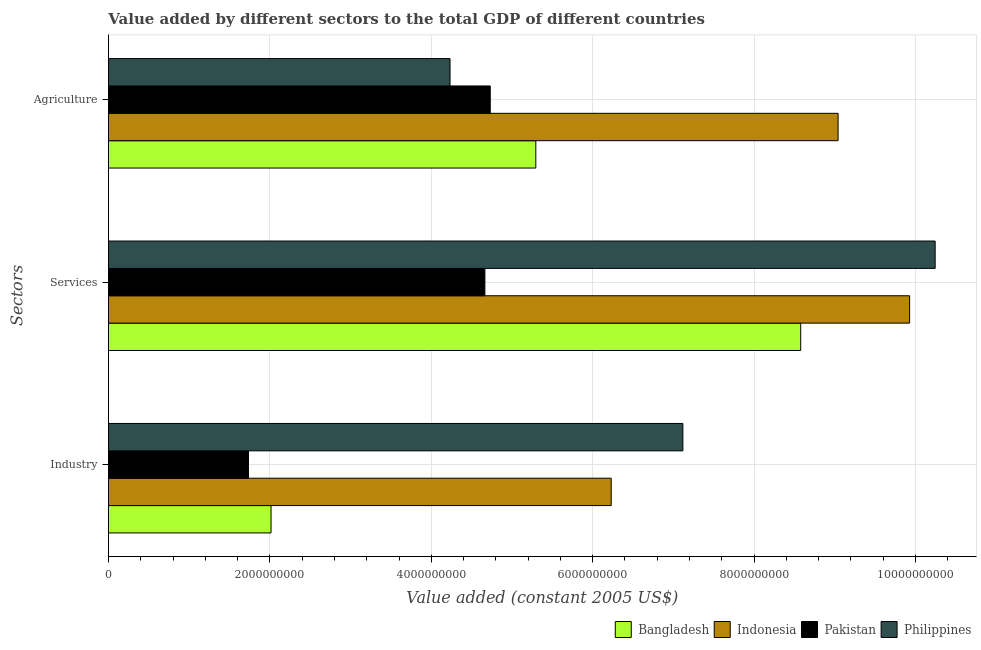How many groups of bars are there?
Offer a very short reply. 3. Are the number of bars per tick equal to the number of legend labels?
Offer a terse response. Yes. Are the number of bars on each tick of the Y-axis equal?
Your answer should be very brief. Yes. How many bars are there on the 3rd tick from the top?
Keep it short and to the point. 4. How many bars are there on the 2nd tick from the bottom?
Provide a succinct answer. 4. What is the label of the 2nd group of bars from the top?
Provide a succinct answer. Services. What is the value added by industrial sector in Philippines?
Offer a very short reply. 7.12e+09. Across all countries, what is the maximum value added by services?
Offer a terse response. 1.02e+1. Across all countries, what is the minimum value added by industrial sector?
Make the answer very short. 1.74e+09. In which country was the value added by industrial sector maximum?
Offer a very short reply. Philippines. What is the total value added by services in the graph?
Ensure brevity in your answer.  3.34e+1. What is the difference between the value added by services in Philippines and that in Pakistan?
Offer a very short reply. 5.58e+09. What is the difference between the value added by agricultural sector in Pakistan and the value added by services in Bangladesh?
Your answer should be very brief. -3.85e+09. What is the average value added by industrial sector per country?
Keep it short and to the point. 4.27e+09. What is the difference between the value added by industrial sector and value added by agricultural sector in Indonesia?
Provide a succinct answer. -2.81e+09. In how many countries, is the value added by services greater than 5600000000 US$?
Your response must be concise. 3. What is the ratio of the value added by industrial sector in Philippines to that in Indonesia?
Offer a very short reply. 1.14. Is the value added by agricultural sector in Pakistan less than that in Philippines?
Your answer should be very brief. No. What is the difference between the highest and the second highest value added by services?
Provide a short and direct response. 3.16e+08. What is the difference between the highest and the lowest value added by services?
Your answer should be compact. 5.58e+09. In how many countries, is the value added by agricultural sector greater than the average value added by agricultural sector taken over all countries?
Provide a short and direct response. 1. What does the 2nd bar from the top in Industry represents?
Your answer should be compact. Pakistan. How many countries are there in the graph?
Your response must be concise. 4. What is the difference between two consecutive major ticks on the X-axis?
Your response must be concise. 2.00e+09. Does the graph contain any zero values?
Offer a very short reply. No. Does the graph contain grids?
Provide a short and direct response. Yes. How many legend labels are there?
Your answer should be very brief. 4. What is the title of the graph?
Provide a short and direct response. Value added by different sectors to the total GDP of different countries. Does "Guinea" appear as one of the legend labels in the graph?
Your answer should be very brief. No. What is the label or title of the X-axis?
Your response must be concise. Value added (constant 2005 US$). What is the label or title of the Y-axis?
Your response must be concise. Sectors. What is the Value added (constant 2005 US$) of Bangladesh in Industry?
Your response must be concise. 2.01e+09. What is the Value added (constant 2005 US$) of Indonesia in Industry?
Make the answer very short. 6.23e+09. What is the Value added (constant 2005 US$) in Pakistan in Industry?
Provide a succinct answer. 1.74e+09. What is the Value added (constant 2005 US$) in Philippines in Industry?
Provide a short and direct response. 7.12e+09. What is the Value added (constant 2005 US$) of Bangladesh in Services?
Your answer should be compact. 8.58e+09. What is the Value added (constant 2005 US$) in Indonesia in Services?
Your answer should be compact. 9.93e+09. What is the Value added (constant 2005 US$) of Pakistan in Services?
Provide a succinct answer. 4.66e+09. What is the Value added (constant 2005 US$) of Philippines in Services?
Your answer should be compact. 1.02e+1. What is the Value added (constant 2005 US$) of Bangladesh in Agriculture?
Provide a short and direct response. 5.30e+09. What is the Value added (constant 2005 US$) in Indonesia in Agriculture?
Provide a succinct answer. 9.04e+09. What is the Value added (constant 2005 US$) in Pakistan in Agriculture?
Make the answer very short. 4.73e+09. What is the Value added (constant 2005 US$) in Philippines in Agriculture?
Keep it short and to the point. 4.23e+09. Across all Sectors, what is the maximum Value added (constant 2005 US$) of Bangladesh?
Keep it short and to the point. 8.58e+09. Across all Sectors, what is the maximum Value added (constant 2005 US$) in Indonesia?
Give a very brief answer. 9.93e+09. Across all Sectors, what is the maximum Value added (constant 2005 US$) of Pakistan?
Your answer should be very brief. 4.73e+09. Across all Sectors, what is the maximum Value added (constant 2005 US$) of Philippines?
Ensure brevity in your answer.  1.02e+1. Across all Sectors, what is the minimum Value added (constant 2005 US$) of Bangladesh?
Keep it short and to the point. 2.01e+09. Across all Sectors, what is the minimum Value added (constant 2005 US$) of Indonesia?
Your response must be concise. 6.23e+09. Across all Sectors, what is the minimum Value added (constant 2005 US$) in Pakistan?
Provide a short and direct response. 1.74e+09. Across all Sectors, what is the minimum Value added (constant 2005 US$) in Philippines?
Keep it short and to the point. 4.23e+09. What is the total Value added (constant 2005 US$) in Bangladesh in the graph?
Provide a succinct answer. 1.59e+1. What is the total Value added (constant 2005 US$) in Indonesia in the graph?
Make the answer very short. 2.52e+1. What is the total Value added (constant 2005 US$) of Pakistan in the graph?
Your response must be concise. 1.11e+1. What is the total Value added (constant 2005 US$) of Philippines in the graph?
Ensure brevity in your answer.  2.16e+1. What is the difference between the Value added (constant 2005 US$) of Bangladesh in Industry and that in Services?
Your answer should be very brief. -6.56e+09. What is the difference between the Value added (constant 2005 US$) of Indonesia in Industry and that in Services?
Ensure brevity in your answer.  -3.70e+09. What is the difference between the Value added (constant 2005 US$) in Pakistan in Industry and that in Services?
Make the answer very short. -2.93e+09. What is the difference between the Value added (constant 2005 US$) of Philippines in Industry and that in Services?
Keep it short and to the point. -3.13e+09. What is the difference between the Value added (constant 2005 US$) of Bangladesh in Industry and that in Agriculture?
Keep it short and to the point. -3.28e+09. What is the difference between the Value added (constant 2005 US$) in Indonesia in Industry and that in Agriculture?
Make the answer very short. -2.81e+09. What is the difference between the Value added (constant 2005 US$) in Pakistan in Industry and that in Agriculture?
Keep it short and to the point. -3.00e+09. What is the difference between the Value added (constant 2005 US$) in Philippines in Industry and that in Agriculture?
Provide a succinct answer. 2.89e+09. What is the difference between the Value added (constant 2005 US$) of Bangladesh in Services and that in Agriculture?
Give a very brief answer. 3.28e+09. What is the difference between the Value added (constant 2005 US$) of Indonesia in Services and that in Agriculture?
Ensure brevity in your answer.  8.86e+08. What is the difference between the Value added (constant 2005 US$) of Pakistan in Services and that in Agriculture?
Your answer should be very brief. -6.64e+07. What is the difference between the Value added (constant 2005 US$) of Philippines in Services and that in Agriculture?
Offer a very short reply. 6.01e+09. What is the difference between the Value added (constant 2005 US$) of Bangladesh in Industry and the Value added (constant 2005 US$) of Indonesia in Services?
Offer a terse response. -7.91e+09. What is the difference between the Value added (constant 2005 US$) in Bangladesh in Industry and the Value added (constant 2005 US$) in Pakistan in Services?
Offer a terse response. -2.65e+09. What is the difference between the Value added (constant 2005 US$) of Bangladesh in Industry and the Value added (constant 2005 US$) of Philippines in Services?
Provide a succinct answer. -8.23e+09. What is the difference between the Value added (constant 2005 US$) in Indonesia in Industry and the Value added (constant 2005 US$) in Pakistan in Services?
Your response must be concise. 1.56e+09. What is the difference between the Value added (constant 2005 US$) in Indonesia in Industry and the Value added (constant 2005 US$) in Philippines in Services?
Keep it short and to the point. -4.01e+09. What is the difference between the Value added (constant 2005 US$) in Pakistan in Industry and the Value added (constant 2005 US$) in Philippines in Services?
Your answer should be compact. -8.51e+09. What is the difference between the Value added (constant 2005 US$) in Bangladesh in Industry and the Value added (constant 2005 US$) in Indonesia in Agriculture?
Your answer should be very brief. -7.03e+09. What is the difference between the Value added (constant 2005 US$) in Bangladesh in Industry and the Value added (constant 2005 US$) in Pakistan in Agriculture?
Your answer should be very brief. -2.72e+09. What is the difference between the Value added (constant 2005 US$) in Bangladesh in Industry and the Value added (constant 2005 US$) in Philippines in Agriculture?
Offer a terse response. -2.22e+09. What is the difference between the Value added (constant 2005 US$) in Indonesia in Industry and the Value added (constant 2005 US$) in Pakistan in Agriculture?
Provide a short and direct response. 1.50e+09. What is the difference between the Value added (constant 2005 US$) of Indonesia in Industry and the Value added (constant 2005 US$) of Philippines in Agriculture?
Offer a very short reply. 2.00e+09. What is the difference between the Value added (constant 2005 US$) in Pakistan in Industry and the Value added (constant 2005 US$) in Philippines in Agriculture?
Provide a short and direct response. -2.50e+09. What is the difference between the Value added (constant 2005 US$) of Bangladesh in Services and the Value added (constant 2005 US$) of Indonesia in Agriculture?
Keep it short and to the point. -4.63e+08. What is the difference between the Value added (constant 2005 US$) in Bangladesh in Services and the Value added (constant 2005 US$) in Pakistan in Agriculture?
Keep it short and to the point. 3.85e+09. What is the difference between the Value added (constant 2005 US$) in Bangladesh in Services and the Value added (constant 2005 US$) in Philippines in Agriculture?
Keep it short and to the point. 4.34e+09. What is the difference between the Value added (constant 2005 US$) of Indonesia in Services and the Value added (constant 2005 US$) of Pakistan in Agriculture?
Ensure brevity in your answer.  5.20e+09. What is the difference between the Value added (constant 2005 US$) of Indonesia in Services and the Value added (constant 2005 US$) of Philippines in Agriculture?
Ensure brevity in your answer.  5.69e+09. What is the difference between the Value added (constant 2005 US$) in Pakistan in Services and the Value added (constant 2005 US$) in Philippines in Agriculture?
Your answer should be very brief. 4.32e+08. What is the average Value added (constant 2005 US$) of Bangladesh per Sectors?
Ensure brevity in your answer.  5.30e+09. What is the average Value added (constant 2005 US$) in Indonesia per Sectors?
Offer a terse response. 8.40e+09. What is the average Value added (constant 2005 US$) of Pakistan per Sectors?
Offer a very short reply. 3.71e+09. What is the average Value added (constant 2005 US$) of Philippines per Sectors?
Your answer should be very brief. 7.20e+09. What is the difference between the Value added (constant 2005 US$) of Bangladesh and Value added (constant 2005 US$) of Indonesia in Industry?
Provide a short and direct response. -4.21e+09. What is the difference between the Value added (constant 2005 US$) of Bangladesh and Value added (constant 2005 US$) of Pakistan in Industry?
Your answer should be very brief. 2.80e+08. What is the difference between the Value added (constant 2005 US$) in Bangladesh and Value added (constant 2005 US$) in Philippines in Industry?
Provide a succinct answer. -5.10e+09. What is the difference between the Value added (constant 2005 US$) of Indonesia and Value added (constant 2005 US$) of Pakistan in Industry?
Your answer should be compact. 4.49e+09. What is the difference between the Value added (constant 2005 US$) of Indonesia and Value added (constant 2005 US$) of Philippines in Industry?
Your answer should be very brief. -8.88e+08. What is the difference between the Value added (constant 2005 US$) of Pakistan and Value added (constant 2005 US$) of Philippines in Industry?
Provide a short and direct response. -5.38e+09. What is the difference between the Value added (constant 2005 US$) in Bangladesh and Value added (constant 2005 US$) in Indonesia in Services?
Provide a succinct answer. -1.35e+09. What is the difference between the Value added (constant 2005 US$) of Bangladesh and Value added (constant 2005 US$) of Pakistan in Services?
Give a very brief answer. 3.91e+09. What is the difference between the Value added (constant 2005 US$) of Bangladesh and Value added (constant 2005 US$) of Philippines in Services?
Offer a terse response. -1.67e+09. What is the difference between the Value added (constant 2005 US$) in Indonesia and Value added (constant 2005 US$) in Pakistan in Services?
Your response must be concise. 5.26e+09. What is the difference between the Value added (constant 2005 US$) of Indonesia and Value added (constant 2005 US$) of Philippines in Services?
Provide a short and direct response. -3.16e+08. What is the difference between the Value added (constant 2005 US$) in Pakistan and Value added (constant 2005 US$) in Philippines in Services?
Make the answer very short. -5.58e+09. What is the difference between the Value added (constant 2005 US$) of Bangladesh and Value added (constant 2005 US$) of Indonesia in Agriculture?
Give a very brief answer. -3.75e+09. What is the difference between the Value added (constant 2005 US$) of Bangladesh and Value added (constant 2005 US$) of Pakistan in Agriculture?
Your response must be concise. 5.65e+08. What is the difference between the Value added (constant 2005 US$) in Bangladesh and Value added (constant 2005 US$) in Philippines in Agriculture?
Give a very brief answer. 1.06e+09. What is the difference between the Value added (constant 2005 US$) of Indonesia and Value added (constant 2005 US$) of Pakistan in Agriculture?
Provide a succinct answer. 4.31e+09. What is the difference between the Value added (constant 2005 US$) in Indonesia and Value added (constant 2005 US$) in Philippines in Agriculture?
Your answer should be very brief. 4.81e+09. What is the difference between the Value added (constant 2005 US$) in Pakistan and Value added (constant 2005 US$) in Philippines in Agriculture?
Give a very brief answer. 4.98e+08. What is the ratio of the Value added (constant 2005 US$) in Bangladesh in Industry to that in Services?
Your answer should be compact. 0.23. What is the ratio of the Value added (constant 2005 US$) of Indonesia in Industry to that in Services?
Give a very brief answer. 0.63. What is the ratio of the Value added (constant 2005 US$) in Pakistan in Industry to that in Services?
Your answer should be very brief. 0.37. What is the ratio of the Value added (constant 2005 US$) in Philippines in Industry to that in Services?
Keep it short and to the point. 0.69. What is the ratio of the Value added (constant 2005 US$) in Bangladesh in Industry to that in Agriculture?
Offer a terse response. 0.38. What is the ratio of the Value added (constant 2005 US$) of Indonesia in Industry to that in Agriculture?
Ensure brevity in your answer.  0.69. What is the ratio of the Value added (constant 2005 US$) of Pakistan in Industry to that in Agriculture?
Offer a terse response. 0.37. What is the ratio of the Value added (constant 2005 US$) in Philippines in Industry to that in Agriculture?
Provide a short and direct response. 1.68. What is the ratio of the Value added (constant 2005 US$) of Bangladesh in Services to that in Agriculture?
Your response must be concise. 1.62. What is the ratio of the Value added (constant 2005 US$) in Indonesia in Services to that in Agriculture?
Your response must be concise. 1.1. What is the ratio of the Value added (constant 2005 US$) of Pakistan in Services to that in Agriculture?
Give a very brief answer. 0.99. What is the ratio of the Value added (constant 2005 US$) of Philippines in Services to that in Agriculture?
Provide a short and direct response. 2.42. What is the difference between the highest and the second highest Value added (constant 2005 US$) of Bangladesh?
Provide a succinct answer. 3.28e+09. What is the difference between the highest and the second highest Value added (constant 2005 US$) of Indonesia?
Your answer should be very brief. 8.86e+08. What is the difference between the highest and the second highest Value added (constant 2005 US$) in Pakistan?
Give a very brief answer. 6.64e+07. What is the difference between the highest and the second highest Value added (constant 2005 US$) of Philippines?
Provide a succinct answer. 3.13e+09. What is the difference between the highest and the lowest Value added (constant 2005 US$) of Bangladesh?
Provide a short and direct response. 6.56e+09. What is the difference between the highest and the lowest Value added (constant 2005 US$) of Indonesia?
Your answer should be compact. 3.70e+09. What is the difference between the highest and the lowest Value added (constant 2005 US$) of Pakistan?
Give a very brief answer. 3.00e+09. What is the difference between the highest and the lowest Value added (constant 2005 US$) of Philippines?
Your answer should be compact. 6.01e+09. 